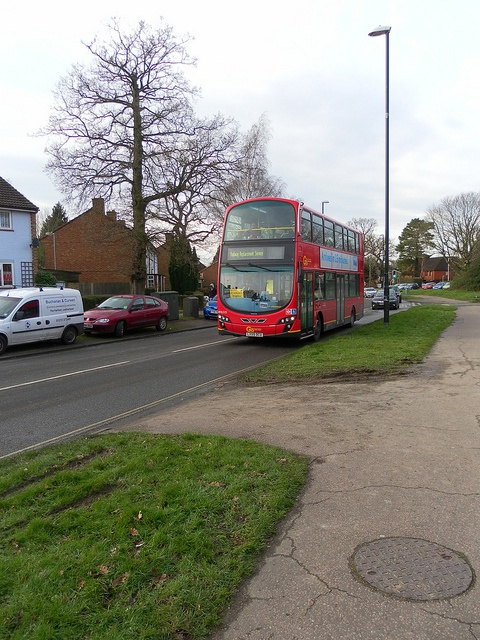Describe the objects in this image and their specific colors. I can see bus in white, gray, black, darkgray, and maroon tones, truck in white, black, darkgray, gray, and lightgray tones, car in white, black, darkgray, gray, and lightgray tones, car in white, black, gray, maroon, and brown tones, and car in white, black, gray, and darkgray tones in this image. 